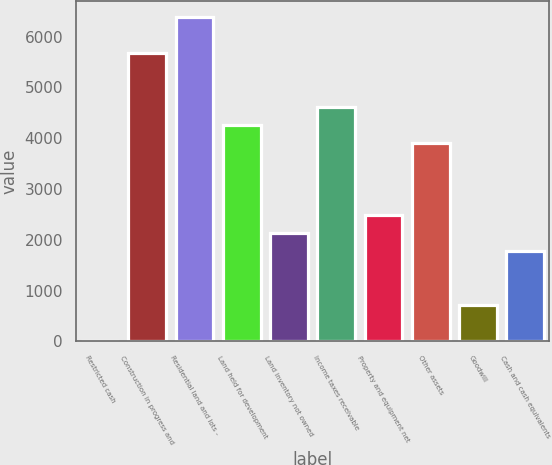Convert chart to OTSL. <chart><loc_0><loc_0><loc_500><loc_500><bar_chart><fcel>Restricted cash<fcel>Construction in progress and<fcel>Residential land and lots -<fcel>Land held for development<fcel>Land inventory not owned<fcel>Income taxes receivable<fcel>Property and equipment net<fcel>Other assets<fcel>Goodwill<fcel>Cash and cash equivalents<nl><fcel>2<fcel>5670.64<fcel>6379.22<fcel>4253.48<fcel>2127.74<fcel>4607.77<fcel>2482.03<fcel>3899.19<fcel>710.58<fcel>1773.45<nl></chart> 